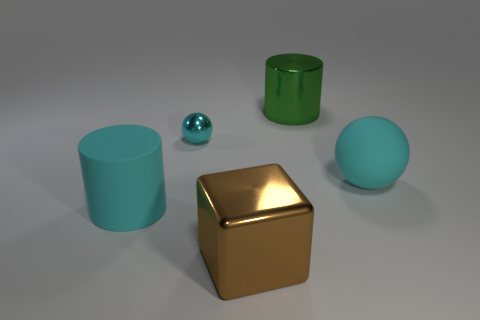Add 3 big cyan spheres. How many objects exist? 8 Subtract all cyan cylinders. How many cylinders are left? 1 Subtract 0 purple balls. How many objects are left? 5 Subtract all cubes. How many objects are left? 4 Subtract all cyan cubes. Subtract all yellow cylinders. How many cubes are left? 1 Subtract all large blue metallic spheres. Subtract all brown metal things. How many objects are left? 4 Add 3 matte objects. How many matte objects are left? 5 Add 3 small yellow matte spheres. How many small yellow matte spheres exist? 3 